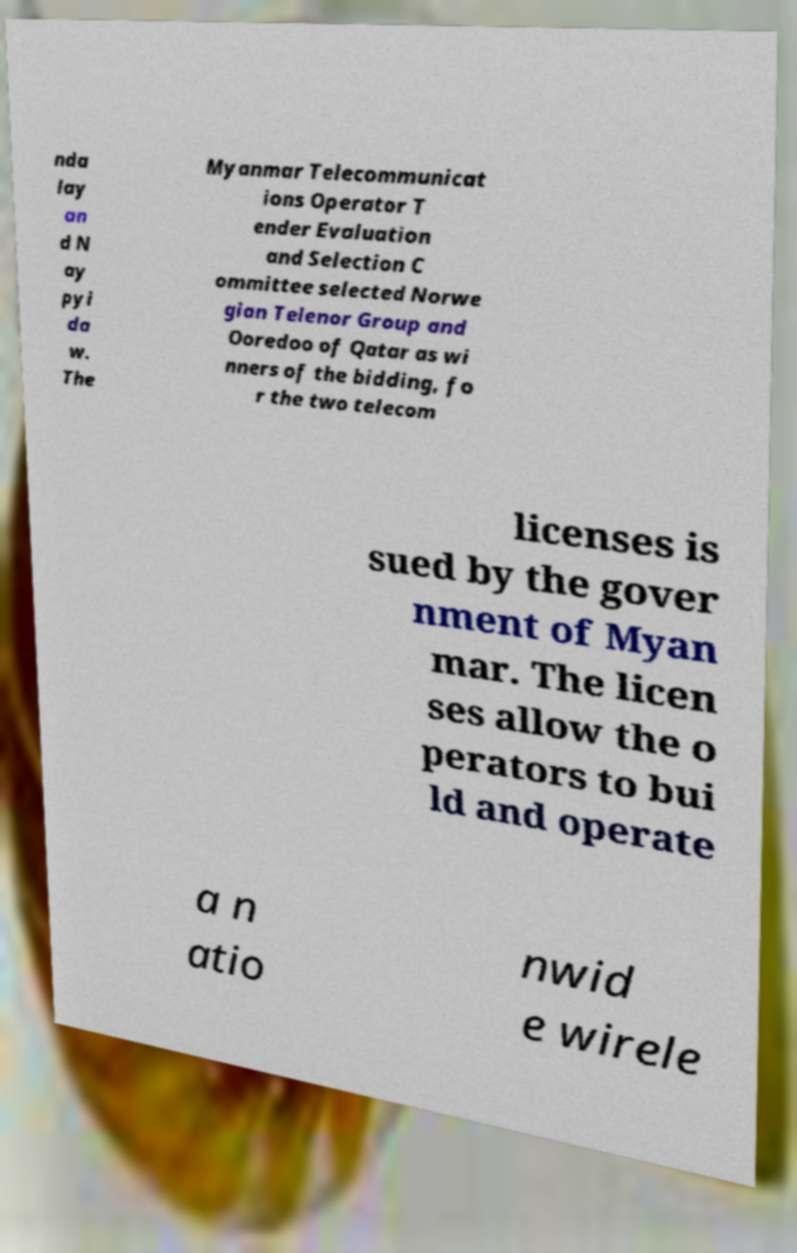For documentation purposes, I need the text within this image transcribed. Could you provide that? nda lay an d N ay pyi da w. The Myanmar Telecommunicat ions Operator T ender Evaluation and Selection C ommittee selected Norwe gian Telenor Group and Ooredoo of Qatar as wi nners of the bidding, fo r the two telecom licenses is sued by the gover nment of Myan mar. The licen ses allow the o perators to bui ld and operate a n atio nwid e wirele 